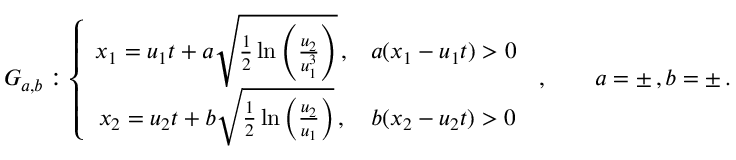<formula> <loc_0><loc_0><loc_500><loc_500>G _ { a , b } \colon \left \{ \begin{array} { c c } { x _ { 1 } = u _ { 1 } t + a \sqrt { \frac { 1 } { 2 } \ln \left ( \frac { u _ { 2 } } { u _ { 1 } ^ { 3 } } \right ) } \, , } & { a ( x _ { 1 } - u _ { 1 } t ) > 0 } \\ { x _ { 2 } = u _ { 2 } t + b \sqrt { \frac { 1 } { 2 } \ln \left ( \frac { u _ { 2 } } { u _ { 1 } } \right ) } \, , } & { b ( x _ { 2 } - u _ { 2 } t ) > 0 } \end{array} \, , \quad a = \pm \, , b = \pm \, .</formula> 